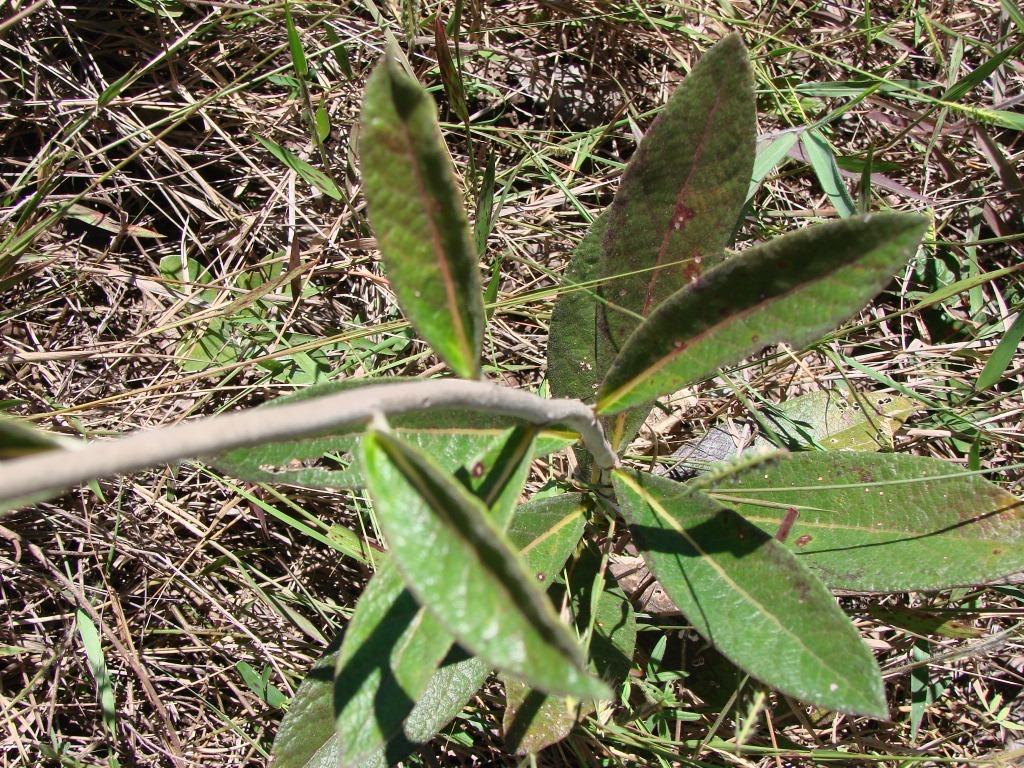In one or two sentences, can you explain what this image depicts? In this image we can see the stem of a plant with some leaves. We can also see some dried grass on the ground. 